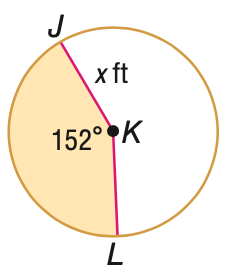Question: The area A of the shaded region is given. Find x. A = 128 ft^2.
Choices:
A. 4.9
B. 6.4
C. 9.8
D. 19.6
Answer with the letter. Answer: C 